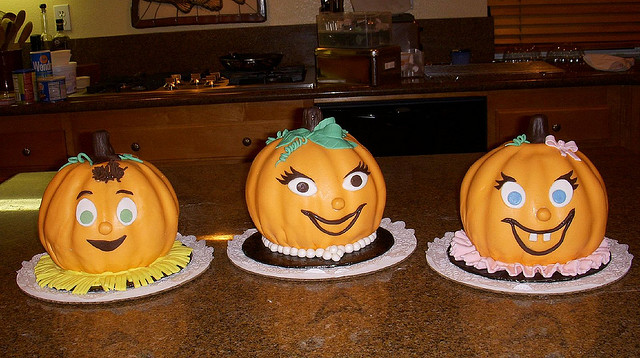What were these made for?
Answer the question using a single word or phrase. Halloween 